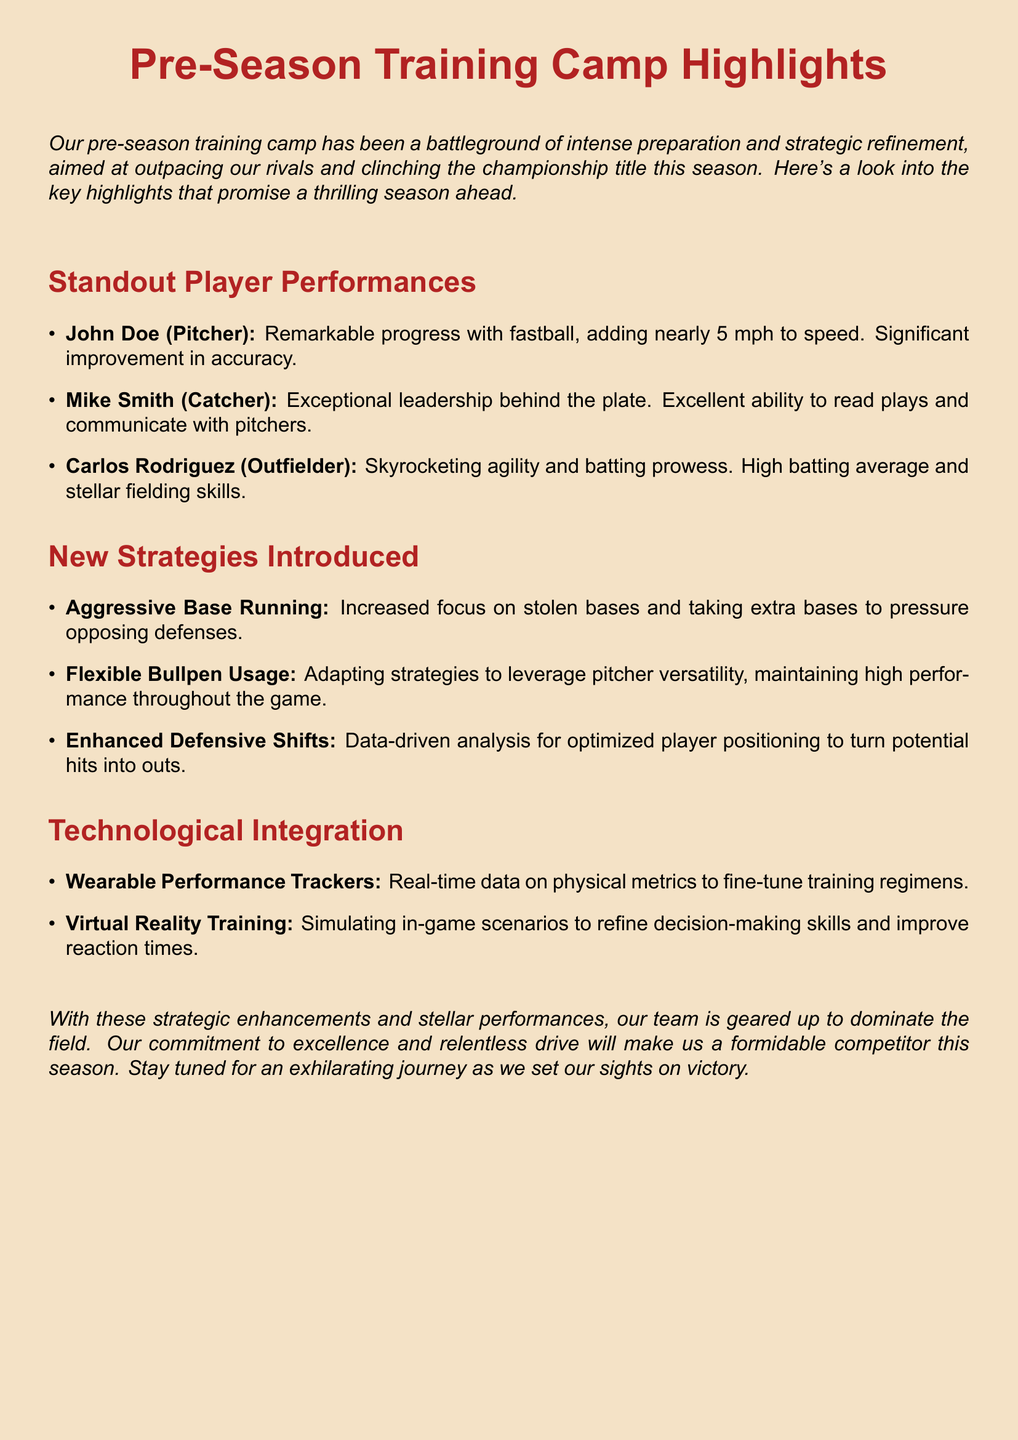What is the highlight of John Doe's performance? John Doe's highlight includes remarkable progress with fastball and significant improvement in accuracy.
Answer: Fastball speed increase What strategy focuses on pressure on opposing defenses? The strategy emphasizing pressure on opposing defenses is detail in the new strategies section.
Answer: Aggressive Base Running What technology is used for training decision-making skills? The technology mentioned for improving decision-making is described in the technological integration section.
Answer: Virtual Reality Training Who showed exceptional leadership as a catcher? The player known for exceptional leadership behind the plate is mentioned in the standout performances.
Answer: Mike Smith What was Carlos Rodriguez's standout skill? Carlos Rodriguez's standout skill relates to his performance in the game as outlined in the document.
Answer: Batting prowess How much speed did John Doe add to his fastball? The document specifies the amount of speed added to John Doe's fastball.
Answer: Nearly 5 mph What is the objective of flexible bullpen usage? The document describes the purpose of this strategy concerning pitcher utilization.
Answer: Leverage pitcher versatility What performance technology provides real-time data? The technology that provides real-time data on physical metrics is described in the integration section.
Answer: Wearable Performance Trackers Which player has a high batting average? The player known for a high batting average is noted in the standout performances section.
Answer: Carlos Rodriguez 